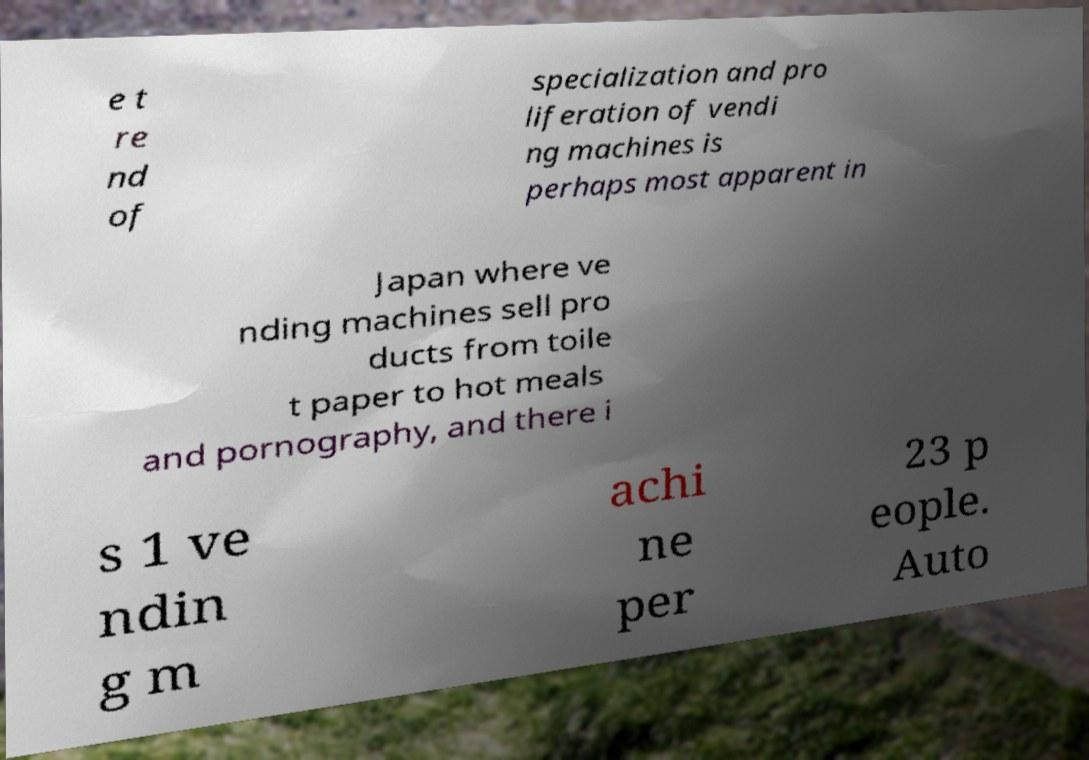Please identify and transcribe the text found in this image. e t re nd of specialization and pro liferation of vendi ng machines is perhaps most apparent in Japan where ve nding machines sell pro ducts from toile t paper to hot meals and pornography, and there i s 1 ve ndin g m achi ne per 23 p eople. Auto 